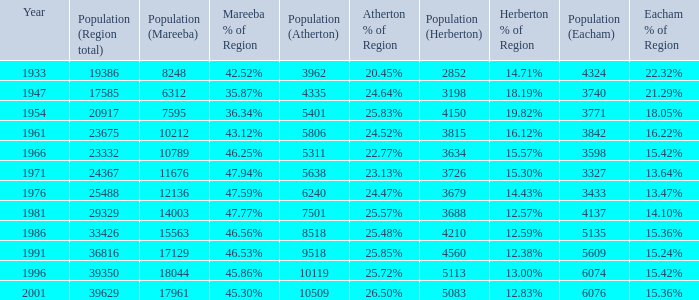How many figures are given for the region's total in 1947? 1.0. 